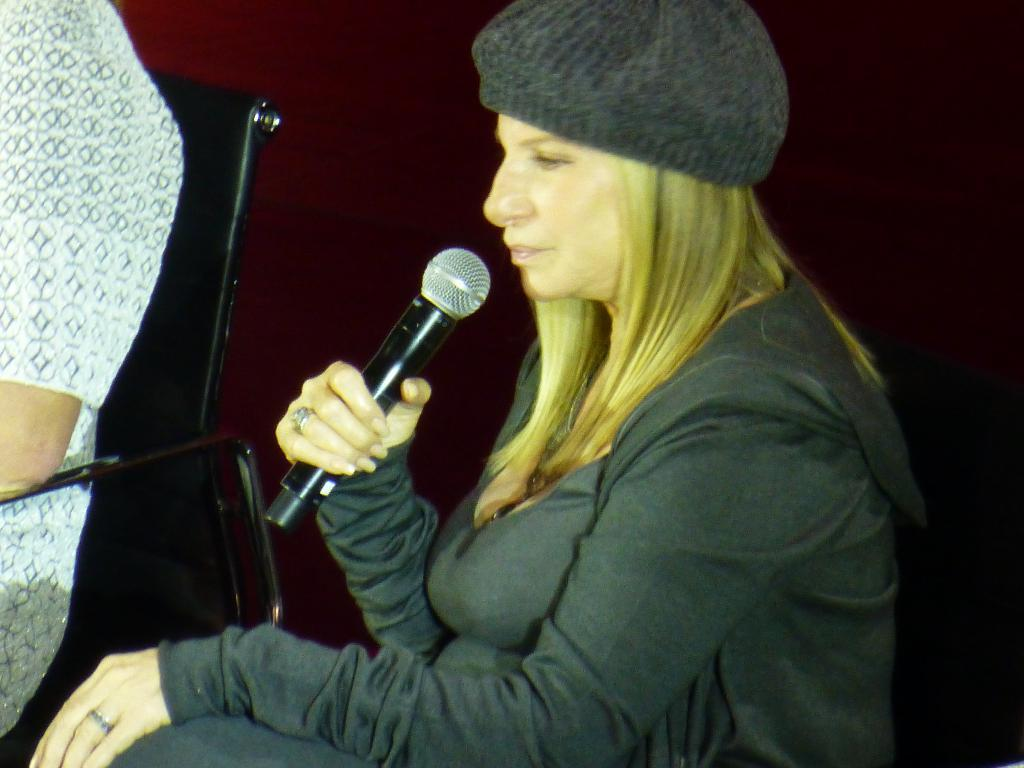Who is the main subject in the image? There is a woman in the image. What is the woman doing in the image? The woman is sitting on a chair and holding a microphone. What is the woman wearing on her head? The woman is wearing a cap. Can you describe the person sitting on the left side of the image? There is a person sitting on a chair on the left side of the image. What type of milk is being poured into the balloon in the image? There is no milk or balloon present in the image. What message of peace is being conveyed by the woman in the image? The image does not convey any specific message of peace; it simply shows a woman sitting on a chair holding a microphone. 